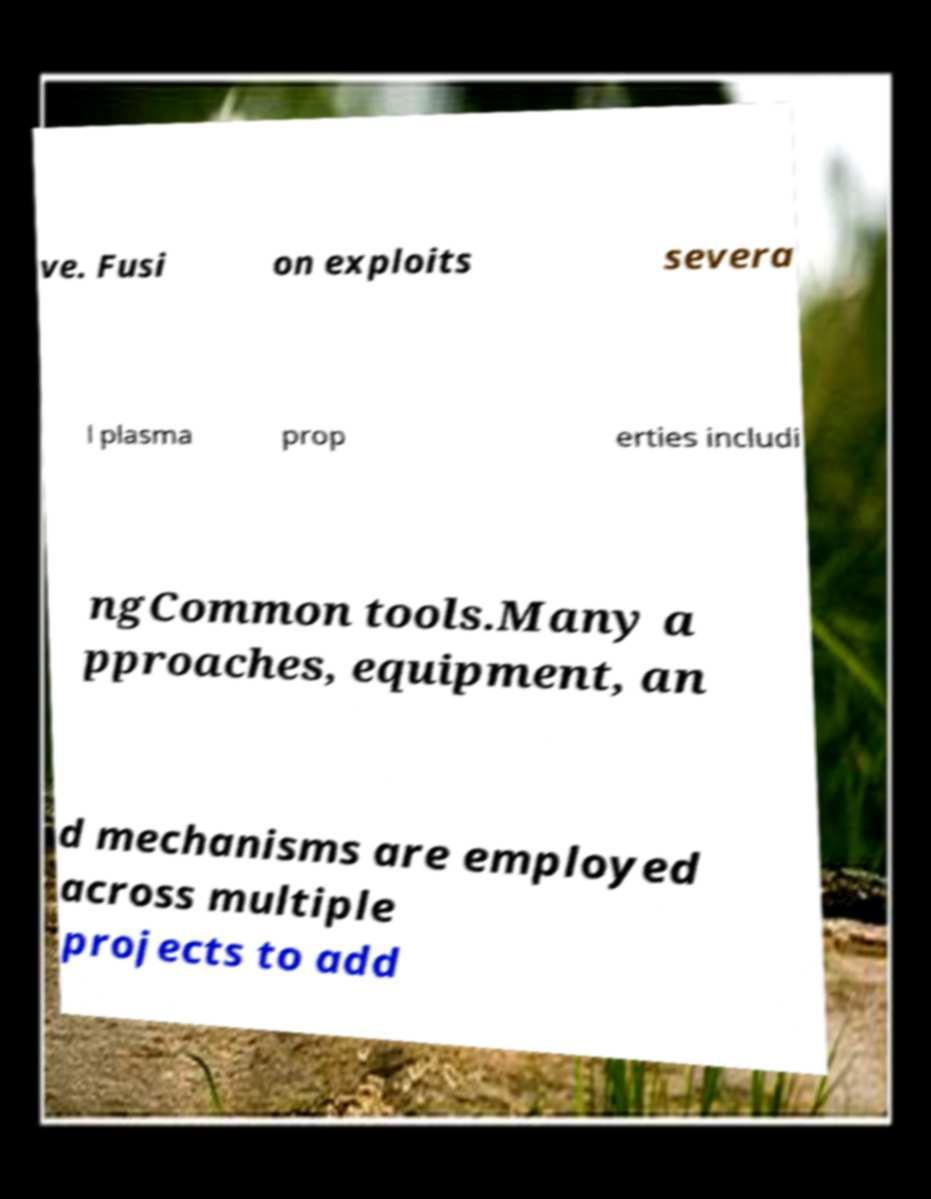Could you assist in decoding the text presented in this image and type it out clearly? ve. Fusi on exploits severa l plasma prop erties includi ngCommon tools.Many a pproaches, equipment, an d mechanisms are employed across multiple projects to add 